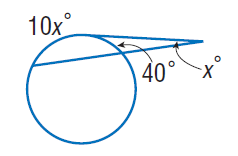Question: Find x. Assume that any segment that appears to be tangent is tangent.
Choices:
A. 5
B. 40
C. 50
D. 90
Answer with the letter. Answer: A 